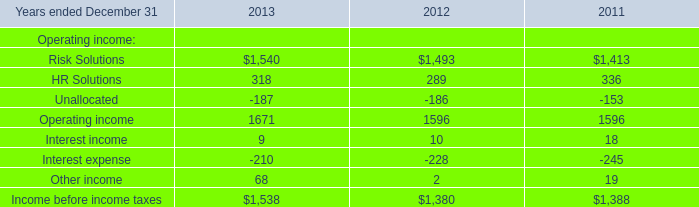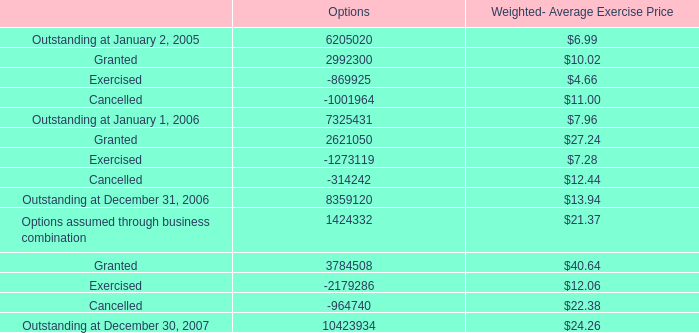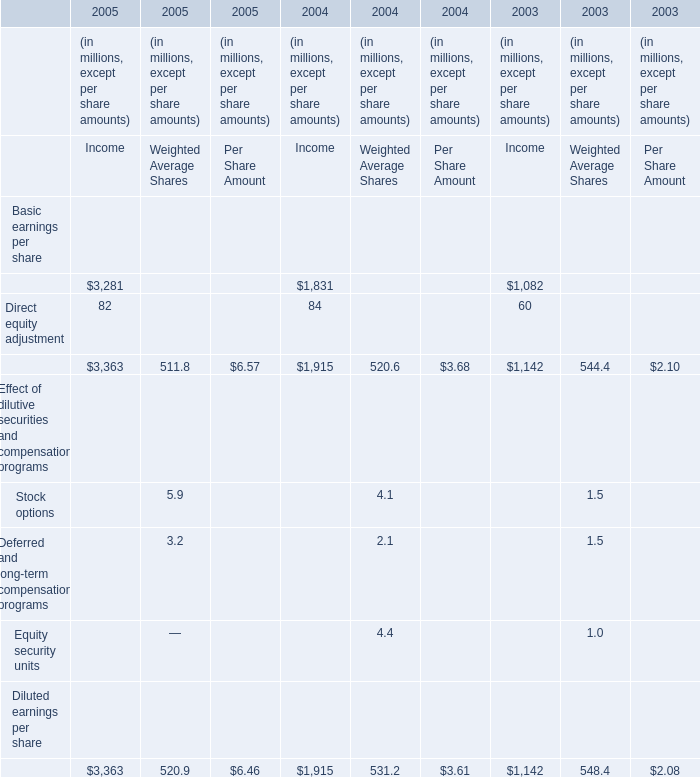What's the average of Risk Solutions of 2013, and Outstanding at December 31, 2006 of Options ? 
Computations: ((1540.0 + 8359120.0) / 2)
Answer: 4180330.0. 